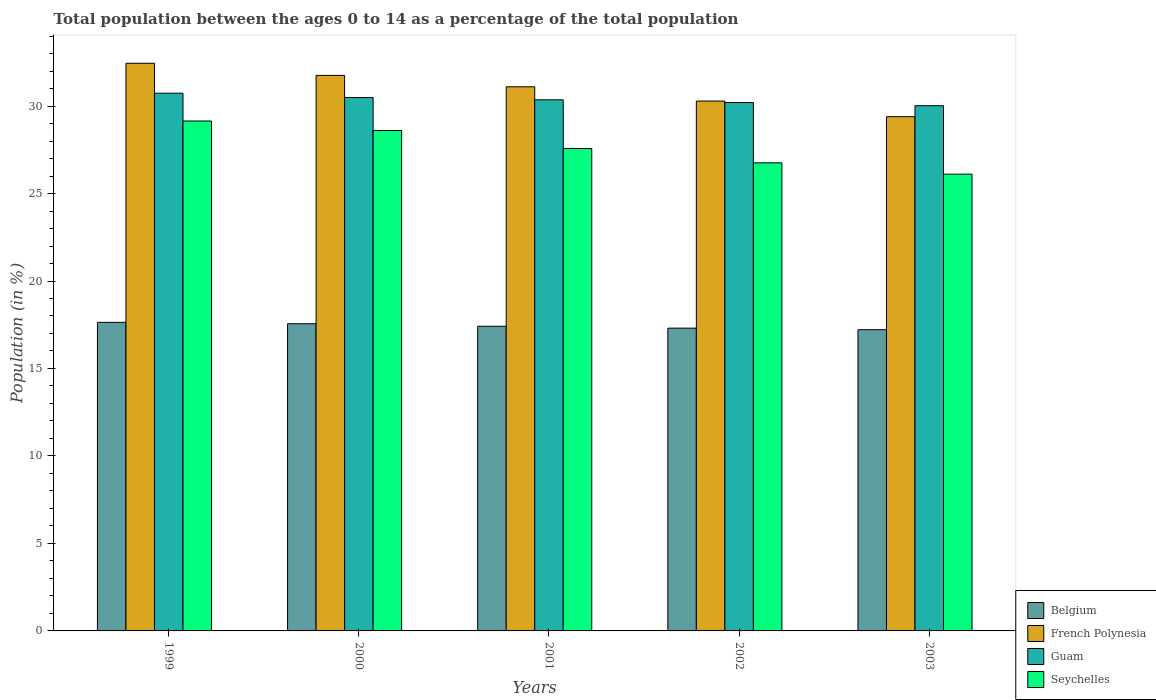How many groups of bars are there?
Your response must be concise. 5. Are the number of bars on each tick of the X-axis equal?
Provide a succinct answer. Yes. What is the percentage of the population ages 0 to 14 in Belgium in 2003?
Your answer should be compact. 17.22. Across all years, what is the maximum percentage of the population ages 0 to 14 in Belgium?
Give a very brief answer. 17.64. Across all years, what is the minimum percentage of the population ages 0 to 14 in French Polynesia?
Make the answer very short. 29.39. In which year was the percentage of the population ages 0 to 14 in Guam minimum?
Make the answer very short. 2003. What is the total percentage of the population ages 0 to 14 in Guam in the graph?
Offer a terse response. 151.8. What is the difference between the percentage of the population ages 0 to 14 in Guam in 2002 and that in 2003?
Provide a succinct answer. 0.18. What is the difference between the percentage of the population ages 0 to 14 in Belgium in 2003 and the percentage of the population ages 0 to 14 in French Polynesia in 2002?
Give a very brief answer. -13.07. What is the average percentage of the population ages 0 to 14 in French Polynesia per year?
Offer a very short reply. 31. In the year 2002, what is the difference between the percentage of the population ages 0 to 14 in Belgium and percentage of the population ages 0 to 14 in French Polynesia?
Provide a succinct answer. -12.98. What is the ratio of the percentage of the population ages 0 to 14 in Belgium in 1999 to that in 2000?
Your response must be concise. 1. Is the percentage of the population ages 0 to 14 in Belgium in 2002 less than that in 2003?
Offer a terse response. No. What is the difference between the highest and the second highest percentage of the population ages 0 to 14 in Guam?
Make the answer very short. 0.25. What is the difference between the highest and the lowest percentage of the population ages 0 to 14 in Guam?
Your answer should be very brief. 0.71. What does the 1st bar from the left in 2002 represents?
Your answer should be very brief. Belgium. What does the 2nd bar from the right in 2003 represents?
Keep it short and to the point. Guam. Are all the bars in the graph horizontal?
Make the answer very short. No. How many years are there in the graph?
Keep it short and to the point. 5. What is the difference between two consecutive major ticks on the Y-axis?
Make the answer very short. 5. Does the graph contain any zero values?
Offer a terse response. No. Does the graph contain grids?
Offer a very short reply. No. Where does the legend appear in the graph?
Your answer should be very brief. Bottom right. How many legend labels are there?
Your response must be concise. 4. What is the title of the graph?
Your response must be concise. Total population between the ages 0 to 14 as a percentage of the total population. What is the Population (in %) of Belgium in 1999?
Make the answer very short. 17.64. What is the Population (in %) of French Polynesia in 1999?
Provide a succinct answer. 32.45. What is the Population (in %) of Guam in 1999?
Your answer should be very brief. 30.73. What is the Population (in %) of Seychelles in 1999?
Offer a very short reply. 29.14. What is the Population (in %) of Belgium in 2000?
Provide a short and direct response. 17.56. What is the Population (in %) of French Polynesia in 2000?
Provide a succinct answer. 31.75. What is the Population (in %) of Guam in 2000?
Your answer should be very brief. 30.49. What is the Population (in %) of Seychelles in 2000?
Provide a short and direct response. 28.6. What is the Population (in %) in Belgium in 2001?
Your answer should be very brief. 17.41. What is the Population (in %) of French Polynesia in 2001?
Provide a succinct answer. 31.1. What is the Population (in %) in Guam in 2001?
Provide a succinct answer. 30.36. What is the Population (in %) in Seychelles in 2001?
Offer a very short reply. 27.57. What is the Population (in %) in Belgium in 2002?
Your answer should be compact. 17.31. What is the Population (in %) in French Polynesia in 2002?
Provide a succinct answer. 30.29. What is the Population (in %) of Guam in 2002?
Offer a terse response. 30.2. What is the Population (in %) of Seychelles in 2002?
Offer a very short reply. 26.75. What is the Population (in %) of Belgium in 2003?
Make the answer very short. 17.22. What is the Population (in %) of French Polynesia in 2003?
Give a very brief answer. 29.39. What is the Population (in %) of Guam in 2003?
Your answer should be compact. 30.02. What is the Population (in %) of Seychelles in 2003?
Provide a succinct answer. 26.11. Across all years, what is the maximum Population (in %) of Belgium?
Provide a short and direct response. 17.64. Across all years, what is the maximum Population (in %) of French Polynesia?
Offer a terse response. 32.45. Across all years, what is the maximum Population (in %) in Guam?
Offer a terse response. 30.73. Across all years, what is the maximum Population (in %) in Seychelles?
Offer a very short reply. 29.14. Across all years, what is the minimum Population (in %) of Belgium?
Provide a short and direct response. 17.22. Across all years, what is the minimum Population (in %) of French Polynesia?
Your response must be concise. 29.39. Across all years, what is the minimum Population (in %) in Guam?
Your answer should be compact. 30.02. Across all years, what is the minimum Population (in %) of Seychelles?
Offer a very short reply. 26.11. What is the total Population (in %) of Belgium in the graph?
Offer a terse response. 87.13. What is the total Population (in %) in French Polynesia in the graph?
Your answer should be very brief. 154.98. What is the total Population (in %) of Guam in the graph?
Keep it short and to the point. 151.8. What is the total Population (in %) in Seychelles in the graph?
Your answer should be compact. 138.18. What is the difference between the Population (in %) of Belgium in 1999 and that in 2000?
Give a very brief answer. 0.08. What is the difference between the Population (in %) in French Polynesia in 1999 and that in 2000?
Ensure brevity in your answer.  0.69. What is the difference between the Population (in %) of Guam in 1999 and that in 2000?
Your response must be concise. 0.25. What is the difference between the Population (in %) in Seychelles in 1999 and that in 2000?
Provide a short and direct response. 0.54. What is the difference between the Population (in %) in Belgium in 1999 and that in 2001?
Your response must be concise. 0.22. What is the difference between the Population (in %) of French Polynesia in 1999 and that in 2001?
Your response must be concise. 1.35. What is the difference between the Population (in %) in Guam in 1999 and that in 2001?
Keep it short and to the point. 0.38. What is the difference between the Population (in %) in Seychelles in 1999 and that in 2001?
Your answer should be very brief. 1.57. What is the difference between the Population (in %) of Belgium in 1999 and that in 2002?
Ensure brevity in your answer.  0.33. What is the difference between the Population (in %) of French Polynesia in 1999 and that in 2002?
Provide a succinct answer. 2.16. What is the difference between the Population (in %) of Guam in 1999 and that in 2002?
Make the answer very short. 0.53. What is the difference between the Population (in %) in Seychelles in 1999 and that in 2002?
Give a very brief answer. 2.39. What is the difference between the Population (in %) in Belgium in 1999 and that in 2003?
Offer a very short reply. 0.42. What is the difference between the Population (in %) in French Polynesia in 1999 and that in 2003?
Your answer should be very brief. 3.05. What is the difference between the Population (in %) of Guam in 1999 and that in 2003?
Your answer should be compact. 0.71. What is the difference between the Population (in %) of Seychelles in 1999 and that in 2003?
Provide a short and direct response. 3.04. What is the difference between the Population (in %) of Belgium in 2000 and that in 2001?
Keep it short and to the point. 0.14. What is the difference between the Population (in %) in French Polynesia in 2000 and that in 2001?
Keep it short and to the point. 0.65. What is the difference between the Population (in %) of Guam in 2000 and that in 2001?
Your response must be concise. 0.13. What is the difference between the Population (in %) in Seychelles in 2000 and that in 2001?
Give a very brief answer. 1.03. What is the difference between the Population (in %) of Belgium in 2000 and that in 2002?
Your response must be concise. 0.25. What is the difference between the Population (in %) of French Polynesia in 2000 and that in 2002?
Offer a very short reply. 1.47. What is the difference between the Population (in %) of Guam in 2000 and that in 2002?
Provide a short and direct response. 0.28. What is the difference between the Population (in %) of Seychelles in 2000 and that in 2002?
Provide a short and direct response. 1.85. What is the difference between the Population (in %) of Belgium in 2000 and that in 2003?
Your response must be concise. 0.34. What is the difference between the Population (in %) in French Polynesia in 2000 and that in 2003?
Make the answer very short. 2.36. What is the difference between the Population (in %) in Guam in 2000 and that in 2003?
Offer a very short reply. 0.47. What is the difference between the Population (in %) of Seychelles in 2000 and that in 2003?
Keep it short and to the point. 2.5. What is the difference between the Population (in %) of Belgium in 2001 and that in 2002?
Ensure brevity in your answer.  0.11. What is the difference between the Population (in %) in French Polynesia in 2001 and that in 2002?
Your answer should be compact. 0.82. What is the difference between the Population (in %) in Guam in 2001 and that in 2002?
Your answer should be compact. 0.16. What is the difference between the Population (in %) of Seychelles in 2001 and that in 2002?
Offer a terse response. 0.82. What is the difference between the Population (in %) of Belgium in 2001 and that in 2003?
Your answer should be very brief. 0.2. What is the difference between the Population (in %) in French Polynesia in 2001 and that in 2003?
Offer a terse response. 1.71. What is the difference between the Population (in %) in Guam in 2001 and that in 2003?
Make the answer very short. 0.34. What is the difference between the Population (in %) in Seychelles in 2001 and that in 2003?
Your response must be concise. 1.46. What is the difference between the Population (in %) of Belgium in 2002 and that in 2003?
Keep it short and to the point. 0.09. What is the difference between the Population (in %) in French Polynesia in 2002 and that in 2003?
Your answer should be very brief. 0.89. What is the difference between the Population (in %) in Guam in 2002 and that in 2003?
Your answer should be compact. 0.18. What is the difference between the Population (in %) in Seychelles in 2002 and that in 2003?
Offer a very short reply. 0.65. What is the difference between the Population (in %) of Belgium in 1999 and the Population (in %) of French Polynesia in 2000?
Your answer should be very brief. -14.12. What is the difference between the Population (in %) of Belgium in 1999 and the Population (in %) of Guam in 2000?
Provide a succinct answer. -12.85. What is the difference between the Population (in %) of Belgium in 1999 and the Population (in %) of Seychelles in 2000?
Ensure brevity in your answer.  -10.97. What is the difference between the Population (in %) of French Polynesia in 1999 and the Population (in %) of Guam in 2000?
Provide a short and direct response. 1.96. What is the difference between the Population (in %) in French Polynesia in 1999 and the Population (in %) in Seychelles in 2000?
Make the answer very short. 3.84. What is the difference between the Population (in %) of Guam in 1999 and the Population (in %) of Seychelles in 2000?
Provide a succinct answer. 2.13. What is the difference between the Population (in %) in Belgium in 1999 and the Population (in %) in French Polynesia in 2001?
Provide a short and direct response. -13.46. What is the difference between the Population (in %) in Belgium in 1999 and the Population (in %) in Guam in 2001?
Your answer should be very brief. -12.72. What is the difference between the Population (in %) of Belgium in 1999 and the Population (in %) of Seychelles in 2001?
Provide a short and direct response. -9.94. What is the difference between the Population (in %) of French Polynesia in 1999 and the Population (in %) of Guam in 2001?
Make the answer very short. 2.09. What is the difference between the Population (in %) of French Polynesia in 1999 and the Population (in %) of Seychelles in 2001?
Offer a terse response. 4.87. What is the difference between the Population (in %) of Guam in 1999 and the Population (in %) of Seychelles in 2001?
Offer a very short reply. 3.16. What is the difference between the Population (in %) of Belgium in 1999 and the Population (in %) of French Polynesia in 2002?
Give a very brief answer. -12.65. What is the difference between the Population (in %) of Belgium in 1999 and the Population (in %) of Guam in 2002?
Make the answer very short. -12.56. What is the difference between the Population (in %) in Belgium in 1999 and the Population (in %) in Seychelles in 2002?
Provide a short and direct response. -9.12. What is the difference between the Population (in %) in French Polynesia in 1999 and the Population (in %) in Guam in 2002?
Offer a very short reply. 2.24. What is the difference between the Population (in %) in French Polynesia in 1999 and the Population (in %) in Seychelles in 2002?
Your answer should be very brief. 5.69. What is the difference between the Population (in %) in Guam in 1999 and the Population (in %) in Seychelles in 2002?
Make the answer very short. 3.98. What is the difference between the Population (in %) of Belgium in 1999 and the Population (in %) of French Polynesia in 2003?
Keep it short and to the point. -11.76. What is the difference between the Population (in %) of Belgium in 1999 and the Population (in %) of Guam in 2003?
Provide a short and direct response. -12.38. What is the difference between the Population (in %) of Belgium in 1999 and the Population (in %) of Seychelles in 2003?
Your answer should be very brief. -8.47. What is the difference between the Population (in %) in French Polynesia in 1999 and the Population (in %) in Guam in 2003?
Provide a succinct answer. 2.43. What is the difference between the Population (in %) of French Polynesia in 1999 and the Population (in %) of Seychelles in 2003?
Offer a terse response. 6.34. What is the difference between the Population (in %) of Guam in 1999 and the Population (in %) of Seychelles in 2003?
Your response must be concise. 4.63. What is the difference between the Population (in %) of Belgium in 2000 and the Population (in %) of French Polynesia in 2001?
Give a very brief answer. -13.54. What is the difference between the Population (in %) in Belgium in 2000 and the Population (in %) in Guam in 2001?
Your answer should be very brief. -12.8. What is the difference between the Population (in %) in Belgium in 2000 and the Population (in %) in Seychelles in 2001?
Ensure brevity in your answer.  -10.01. What is the difference between the Population (in %) of French Polynesia in 2000 and the Population (in %) of Guam in 2001?
Make the answer very short. 1.4. What is the difference between the Population (in %) of French Polynesia in 2000 and the Population (in %) of Seychelles in 2001?
Your response must be concise. 4.18. What is the difference between the Population (in %) of Guam in 2000 and the Population (in %) of Seychelles in 2001?
Give a very brief answer. 2.91. What is the difference between the Population (in %) of Belgium in 2000 and the Population (in %) of French Polynesia in 2002?
Offer a very short reply. -12.73. What is the difference between the Population (in %) in Belgium in 2000 and the Population (in %) in Guam in 2002?
Offer a very short reply. -12.64. What is the difference between the Population (in %) of Belgium in 2000 and the Population (in %) of Seychelles in 2002?
Offer a very short reply. -9.2. What is the difference between the Population (in %) in French Polynesia in 2000 and the Population (in %) in Guam in 2002?
Ensure brevity in your answer.  1.55. What is the difference between the Population (in %) of French Polynesia in 2000 and the Population (in %) of Seychelles in 2002?
Your answer should be very brief. 5. What is the difference between the Population (in %) of Guam in 2000 and the Population (in %) of Seychelles in 2002?
Your response must be concise. 3.73. What is the difference between the Population (in %) of Belgium in 2000 and the Population (in %) of French Polynesia in 2003?
Offer a very short reply. -11.83. What is the difference between the Population (in %) of Belgium in 2000 and the Population (in %) of Guam in 2003?
Offer a terse response. -12.46. What is the difference between the Population (in %) of Belgium in 2000 and the Population (in %) of Seychelles in 2003?
Your answer should be very brief. -8.55. What is the difference between the Population (in %) in French Polynesia in 2000 and the Population (in %) in Guam in 2003?
Provide a short and direct response. 1.73. What is the difference between the Population (in %) of French Polynesia in 2000 and the Population (in %) of Seychelles in 2003?
Your answer should be compact. 5.64. What is the difference between the Population (in %) of Guam in 2000 and the Population (in %) of Seychelles in 2003?
Give a very brief answer. 4.38. What is the difference between the Population (in %) in Belgium in 2001 and the Population (in %) in French Polynesia in 2002?
Keep it short and to the point. -12.87. What is the difference between the Population (in %) in Belgium in 2001 and the Population (in %) in Guam in 2002?
Give a very brief answer. -12.79. What is the difference between the Population (in %) of Belgium in 2001 and the Population (in %) of Seychelles in 2002?
Your answer should be compact. -9.34. What is the difference between the Population (in %) in French Polynesia in 2001 and the Population (in %) in Guam in 2002?
Make the answer very short. 0.9. What is the difference between the Population (in %) of French Polynesia in 2001 and the Population (in %) of Seychelles in 2002?
Offer a terse response. 4.35. What is the difference between the Population (in %) in Guam in 2001 and the Population (in %) in Seychelles in 2002?
Give a very brief answer. 3.6. What is the difference between the Population (in %) of Belgium in 2001 and the Population (in %) of French Polynesia in 2003?
Offer a very short reply. -11.98. What is the difference between the Population (in %) of Belgium in 2001 and the Population (in %) of Guam in 2003?
Give a very brief answer. -12.61. What is the difference between the Population (in %) of Belgium in 2001 and the Population (in %) of Seychelles in 2003?
Provide a short and direct response. -8.69. What is the difference between the Population (in %) in French Polynesia in 2001 and the Population (in %) in Guam in 2003?
Make the answer very short. 1.08. What is the difference between the Population (in %) in French Polynesia in 2001 and the Population (in %) in Seychelles in 2003?
Provide a succinct answer. 4.99. What is the difference between the Population (in %) of Guam in 2001 and the Population (in %) of Seychelles in 2003?
Keep it short and to the point. 4.25. What is the difference between the Population (in %) in Belgium in 2002 and the Population (in %) in French Polynesia in 2003?
Your answer should be very brief. -12.09. What is the difference between the Population (in %) in Belgium in 2002 and the Population (in %) in Guam in 2003?
Provide a succinct answer. -12.71. What is the difference between the Population (in %) in Belgium in 2002 and the Population (in %) in Seychelles in 2003?
Provide a short and direct response. -8.8. What is the difference between the Population (in %) in French Polynesia in 2002 and the Population (in %) in Guam in 2003?
Make the answer very short. 0.26. What is the difference between the Population (in %) of French Polynesia in 2002 and the Population (in %) of Seychelles in 2003?
Your answer should be compact. 4.18. What is the difference between the Population (in %) in Guam in 2002 and the Population (in %) in Seychelles in 2003?
Make the answer very short. 4.09. What is the average Population (in %) of Belgium per year?
Your answer should be compact. 17.43. What is the average Population (in %) of French Polynesia per year?
Your answer should be compact. 31. What is the average Population (in %) in Guam per year?
Your response must be concise. 30.36. What is the average Population (in %) in Seychelles per year?
Provide a short and direct response. 27.64. In the year 1999, what is the difference between the Population (in %) of Belgium and Population (in %) of French Polynesia?
Provide a succinct answer. -14.81. In the year 1999, what is the difference between the Population (in %) in Belgium and Population (in %) in Guam?
Your response must be concise. -13.1. In the year 1999, what is the difference between the Population (in %) in Belgium and Population (in %) in Seychelles?
Make the answer very short. -11.51. In the year 1999, what is the difference between the Population (in %) of French Polynesia and Population (in %) of Guam?
Provide a succinct answer. 1.71. In the year 1999, what is the difference between the Population (in %) in French Polynesia and Population (in %) in Seychelles?
Make the answer very short. 3.3. In the year 1999, what is the difference between the Population (in %) in Guam and Population (in %) in Seychelles?
Make the answer very short. 1.59. In the year 2000, what is the difference between the Population (in %) in Belgium and Population (in %) in French Polynesia?
Offer a very short reply. -14.19. In the year 2000, what is the difference between the Population (in %) of Belgium and Population (in %) of Guam?
Your answer should be very brief. -12.93. In the year 2000, what is the difference between the Population (in %) in Belgium and Population (in %) in Seychelles?
Offer a very short reply. -11.04. In the year 2000, what is the difference between the Population (in %) in French Polynesia and Population (in %) in Guam?
Your response must be concise. 1.27. In the year 2000, what is the difference between the Population (in %) of French Polynesia and Population (in %) of Seychelles?
Ensure brevity in your answer.  3.15. In the year 2000, what is the difference between the Population (in %) of Guam and Population (in %) of Seychelles?
Offer a terse response. 1.88. In the year 2001, what is the difference between the Population (in %) of Belgium and Population (in %) of French Polynesia?
Provide a succinct answer. -13.69. In the year 2001, what is the difference between the Population (in %) in Belgium and Population (in %) in Guam?
Make the answer very short. -12.94. In the year 2001, what is the difference between the Population (in %) of Belgium and Population (in %) of Seychelles?
Keep it short and to the point. -10.16. In the year 2001, what is the difference between the Population (in %) in French Polynesia and Population (in %) in Guam?
Keep it short and to the point. 0.74. In the year 2001, what is the difference between the Population (in %) in French Polynesia and Population (in %) in Seychelles?
Provide a succinct answer. 3.53. In the year 2001, what is the difference between the Population (in %) in Guam and Population (in %) in Seychelles?
Offer a terse response. 2.78. In the year 2002, what is the difference between the Population (in %) of Belgium and Population (in %) of French Polynesia?
Your answer should be compact. -12.98. In the year 2002, what is the difference between the Population (in %) in Belgium and Population (in %) in Guam?
Offer a terse response. -12.9. In the year 2002, what is the difference between the Population (in %) of Belgium and Population (in %) of Seychelles?
Make the answer very short. -9.45. In the year 2002, what is the difference between the Population (in %) in French Polynesia and Population (in %) in Guam?
Ensure brevity in your answer.  0.08. In the year 2002, what is the difference between the Population (in %) in French Polynesia and Population (in %) in Seychelles?
Offer a very short reply. 3.53. In the year 2002, what is the difference between the Population (in %) in Guam and Population (in %) in Seychelles?
Your response must be concise. 3.45. In the year 2003, what is the difference between the Population (in %) in Belgium and Population (in %) in French Polynesia?
Your answer should be very brief. -12.17. In the year 2003, what is the difference between the Population (in %) in Belgium and Population (in %) in Guam?
Keep it short and to the point. -12.8. In the year 2003, what is the difference between the Population (in %) in Belgium and Population (in %) in Seychelles?
Offer a terse response. -8.89. In the year 2003, what is the difference between the Population (in %) of French Polynesia and Population (in %) of Guam?
Your answer should be compact. -0.63. In the year 2003, what is the difference between the Population (in %) in French Polynesia and Population (in %) in Seychelles?
Your answer should be compact. 3.28. In the year 2003, what is the difference between the Population (in %) of Guam and Population (in %) of Seychelles?
Give a very brief answer. 3.91. What is the ratio of the Population (in %) of Belgium in 1999 to that in 2000?
Provide a succinct answer. 1. What is the ratio of the Population (in %) of French Polynesia in 1999 to that in 2000?
Provide a succinct answer. 1.02. What is the ratio of the Population (in %) of Belgium in 1999 to that in 2001?
Offer a very short reply. 1.01. What is the ratio of the Population (in %) in French Polynesia in 1999 to that in 2001?
Your response must be concise. 1.04. What is the ratio of the Population (in %) in Guam in 1999 to that in 2001?
Your answer should be compact. 1.01. What is the ratio of the Population (in %) in Seychelles in 1999 to that in 2001?
Provide a succinct answer. 1.06. What is the ratio of the Population (in %) in Belgium in 1999 to that in 2002?
Your response must be concise. 1.02. What is the ratio of the Population (in %) in French Polynesia in 1999 to that in 2002?
Your response must be concise. 1.07. What is the ratio of the Population (in %) in Guam in 1999 to that in 2002?
Give a very brief answer. 1.02. What is the ratio of the Population (in %) in Seychelles in 1999 to that in 2002?
Offer a very short reply. 1.09. What is the ratio of the Population (in %) of Belgium in 1999 to that in 2003?
Make the answer very short. 1.02. What is the ratio of the Population (in %) in French Polynesia in 1999 to that in 2003?
Your response must be concise. 1.1. What is the ratio of the Population (in %) of Guam in 1999 to that in 2003?
Offer a terse response. 1.02. What is the ratio of the Population (in %) of Seychelles in 1999 to that in 2003?
Your response must be concise. 1.12. What is the ratio of the Population (in %) of Belgium in 2000 to that in 2001?
Offer a very short reply. 1.01. What is the ratio of the Population (in %) of Guam in 2000 to that in 2001?
Ensure brevity in your answer.  1. What is the ratio of the Population (in %) of Seychelles in 2000 to that in 2001?
Your answer should be compact. 1.04. What is the ratio of the Population (in %) of Belgium in 2000 to that in 2002?
Offer a very short reply. 1.01. What is the ratio of the Population (in %) in French Polynesia in 2000 to that in 2002?
Offer a very short reply. 1.05. What is the ratio of the Population (in %) of Guam in 2000 to that in 2002?
Give a very brief answer. 1.01. What is the ratio of the Population (in %) in Seychelles in 2000 to that in 2002?
Offer a terse response. 1.07. What is the ratio of the Population (in %) of Belgium in 2000 to that in 2003?
Give a very brief answer. 1.02. What is the ratio of the Population (in %) in French Polynesia in 2000 to that in 2003?
Give a very brief answer. 1.08. What is the ratio of the Population (in %) in Guam in 2000 to that in 2003?
Ensure brevity in your answer.  1.02. What is the ratio of the Population (in %) of Seychelles in 2000 to that in 2003?
Your answer should be compact. 1.1. What is the ratio of the Population (in %) of Belgium in 2001 to that in 2002?
Provide a succinct answer. 1.01. What is the ratio of the Population (in %) of French Polynesia in 2001 to that in 2002?
Your answer should be compact. 1.03. What is the ratio of the Population (in %) in Guam in 2001 to that in 2002?
Give a very brief answer. 1.01. What is the ratio of the Population (in %) in Seychelles in 2001 to that in 2002?
Keep it short and to the point. 1.03. What is the ratio of the Population (in %) of Belgium in 2001 to that in 2003?
Offer a very short reply. 1.01. What is the ratio of the Population (in %) of French Polynesia in 2001 to that in 2003?
Offer a very short reply. 1.06. What is the ratio of the Population (in %) in Guam in 2001 to that in 2003?
Ensure brevity in your answer.  1.01. What is the ratio of the Population (in %) in Seychelles in 2001 to that in 2003?
Offer a terse response. 1.06. What is the ratio of the Population (in %) in French Polynesia in 2002 to that in 2003?
Ensure brevity in your answer.  1.03. What is the ratio of the Population (in %) of Guam in 2002 to that in 2003?
Offer a terse response. 1.01. What is the ratio of the Population (in %) of Seychelles in 2002 to that in 2003?
Ensure brevity in your answer.  1.02. What is the difference between the highest and the second highest Population (in %) of Belgium?
Give a very brief answer. 0.08. What is the difference between the highest and the second highest Population (in %) of French Polynesia?
Your answer should be compact. 0.69. What is the difference between the highest and the second highest Population (in %) in Guam?
Your answer should be very brief. 0.25. What is the difference between the highest and the second highest Population (in %) in Seychelles?
Provide a succinct answer. 0.54. What is the difference between the highest and the lowest Population (in %) of Belgium?
Your answer should be compact. 0.42. What is the difference between the highest and the lowest Population (in %) in French Polynesia?
Your answer should be very brief. 3.05. What is the difference between the highest and the lowest Population (in %) in Guam?
Your answer should be compact. 0.71. What is the difference between the highest and the lowest Population (in %) in Seychelles?
Provide a short and direct response. 3.04. 